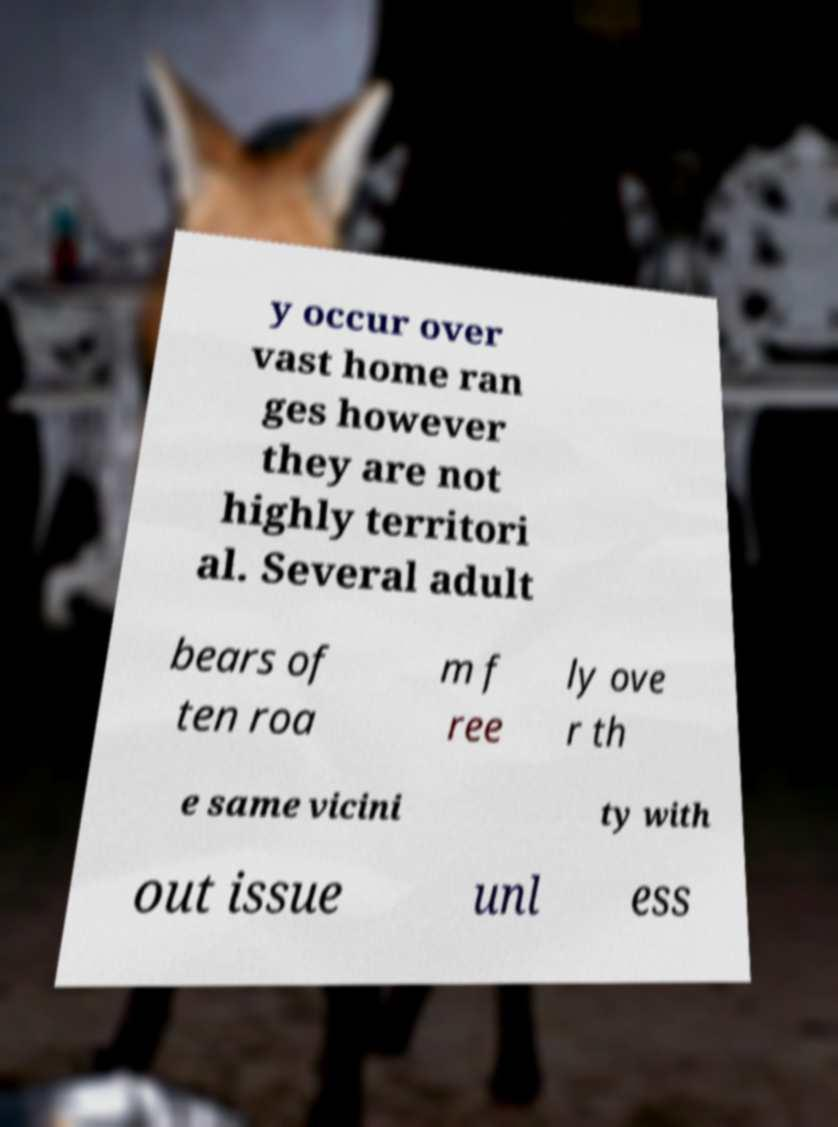There's text embedded in this image that I need extracted. Can you transcribe it verbatim? y occur over vast home ran ges however they are not highly territori al. Several adult bears of ten roa m f ree ly ove r th e same vicini ty with out issue unl ess 